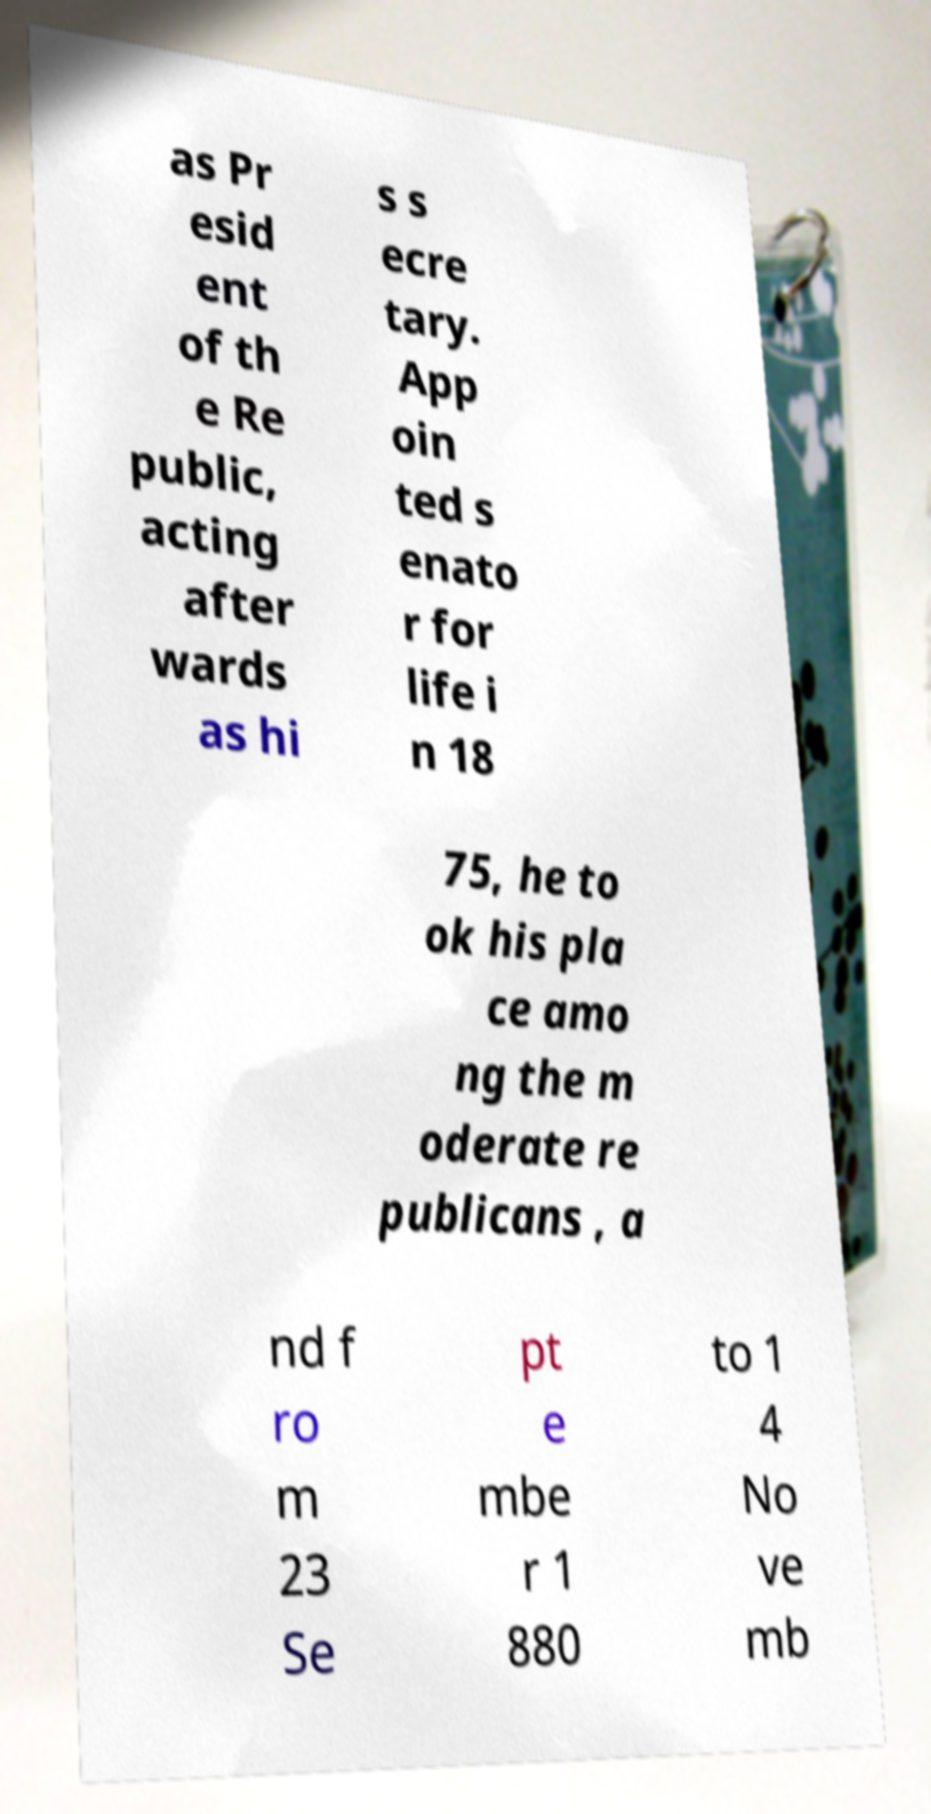Please read and relay the text visible in this image. What does it say? as Pr esid ent of th e Re public, acting after wards as hi s s ecre tary. App oin ted s enato r for life i n 18 75, he to ok his pla ce amo ng the m oderate re publicans , a nd f ro m 23 Se pt e mbe r 1 880 to 1 4 No ve mb 